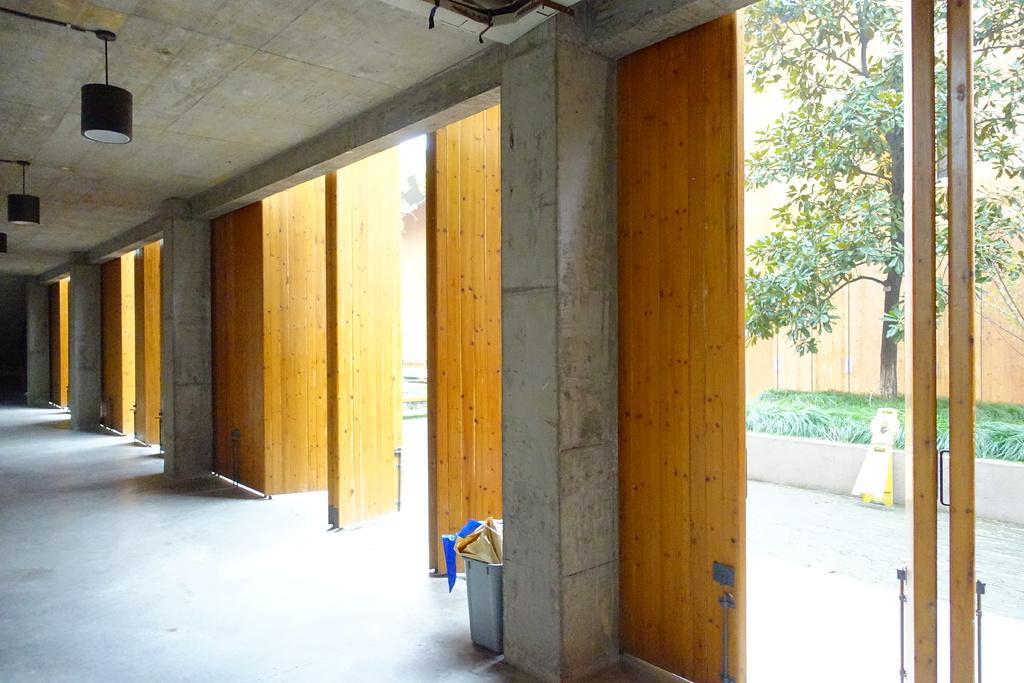Please provide a concise description of this image. In this image I can see pillars, lights on the ceiling and some other objects on the floor. Here I can see a tree, plants, wall and some other objects on the ground. 